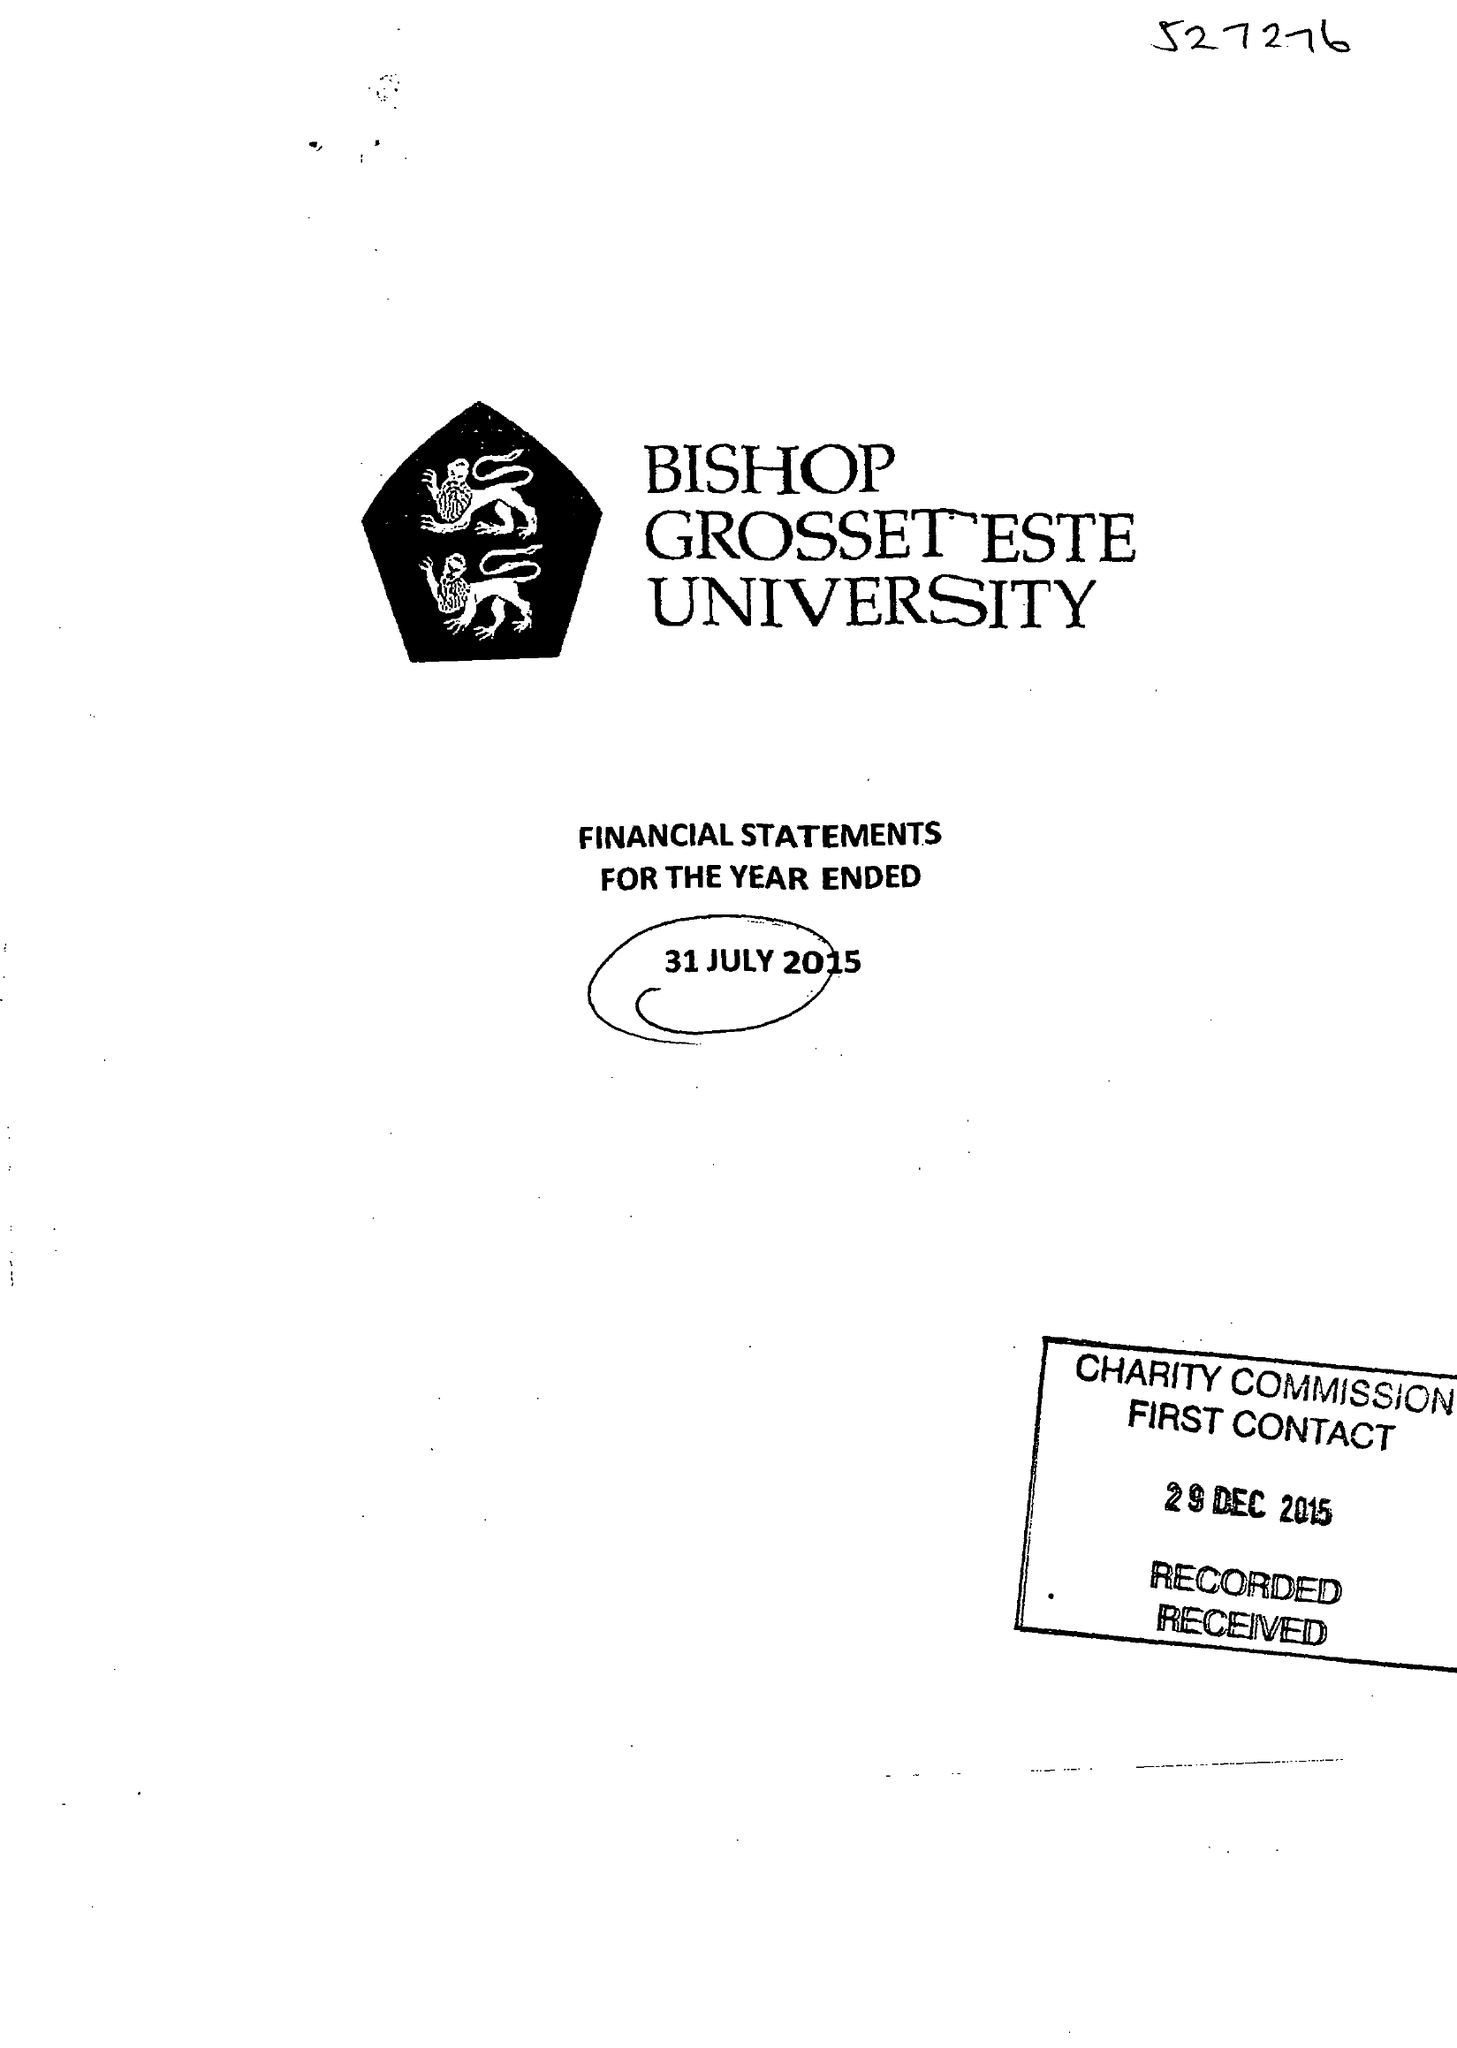What is the value for the spending_annually_in_british_pounds?
Answer the question using a single word or phrase. 17243106.00 